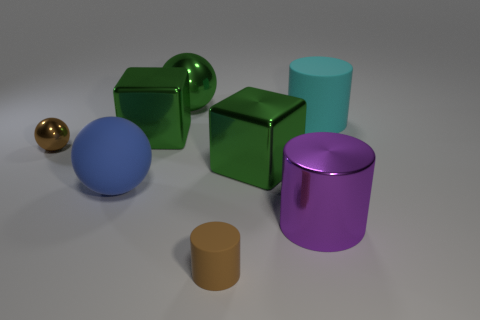Subtract all large cyan cylinders. How many cylinders are left? 2 Subtract all cylinders. How many objects are left? 5 Subtract all green balls. How many balls are left? 2 Add 1 cyan matte objects. How many objects exist? 9 Add 3 blue rubber spheres. How many blue rubber spheres are left? 4 Add 8 small brown metallic spheres. How many small brown metallic spheres exist? 9 Subtract 1 brown cylinders. How many objects are left? 7 Subtract 2 blocks. How many blocks are left? 0 Subtract all red spheres. Subtract all brown cylinders. How many spheres are left? 3 Subtract all green spheres. How many red blocks are left? 0 